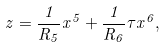<formula> <loc_0><loc_0><loc_500><loc_500>z = \frac { 1 } { R _ { 5 } } x ^ { 5 } + \frac { 1 } { R _ { 6 } } \tau x ^ { 6 } ,</formula> 